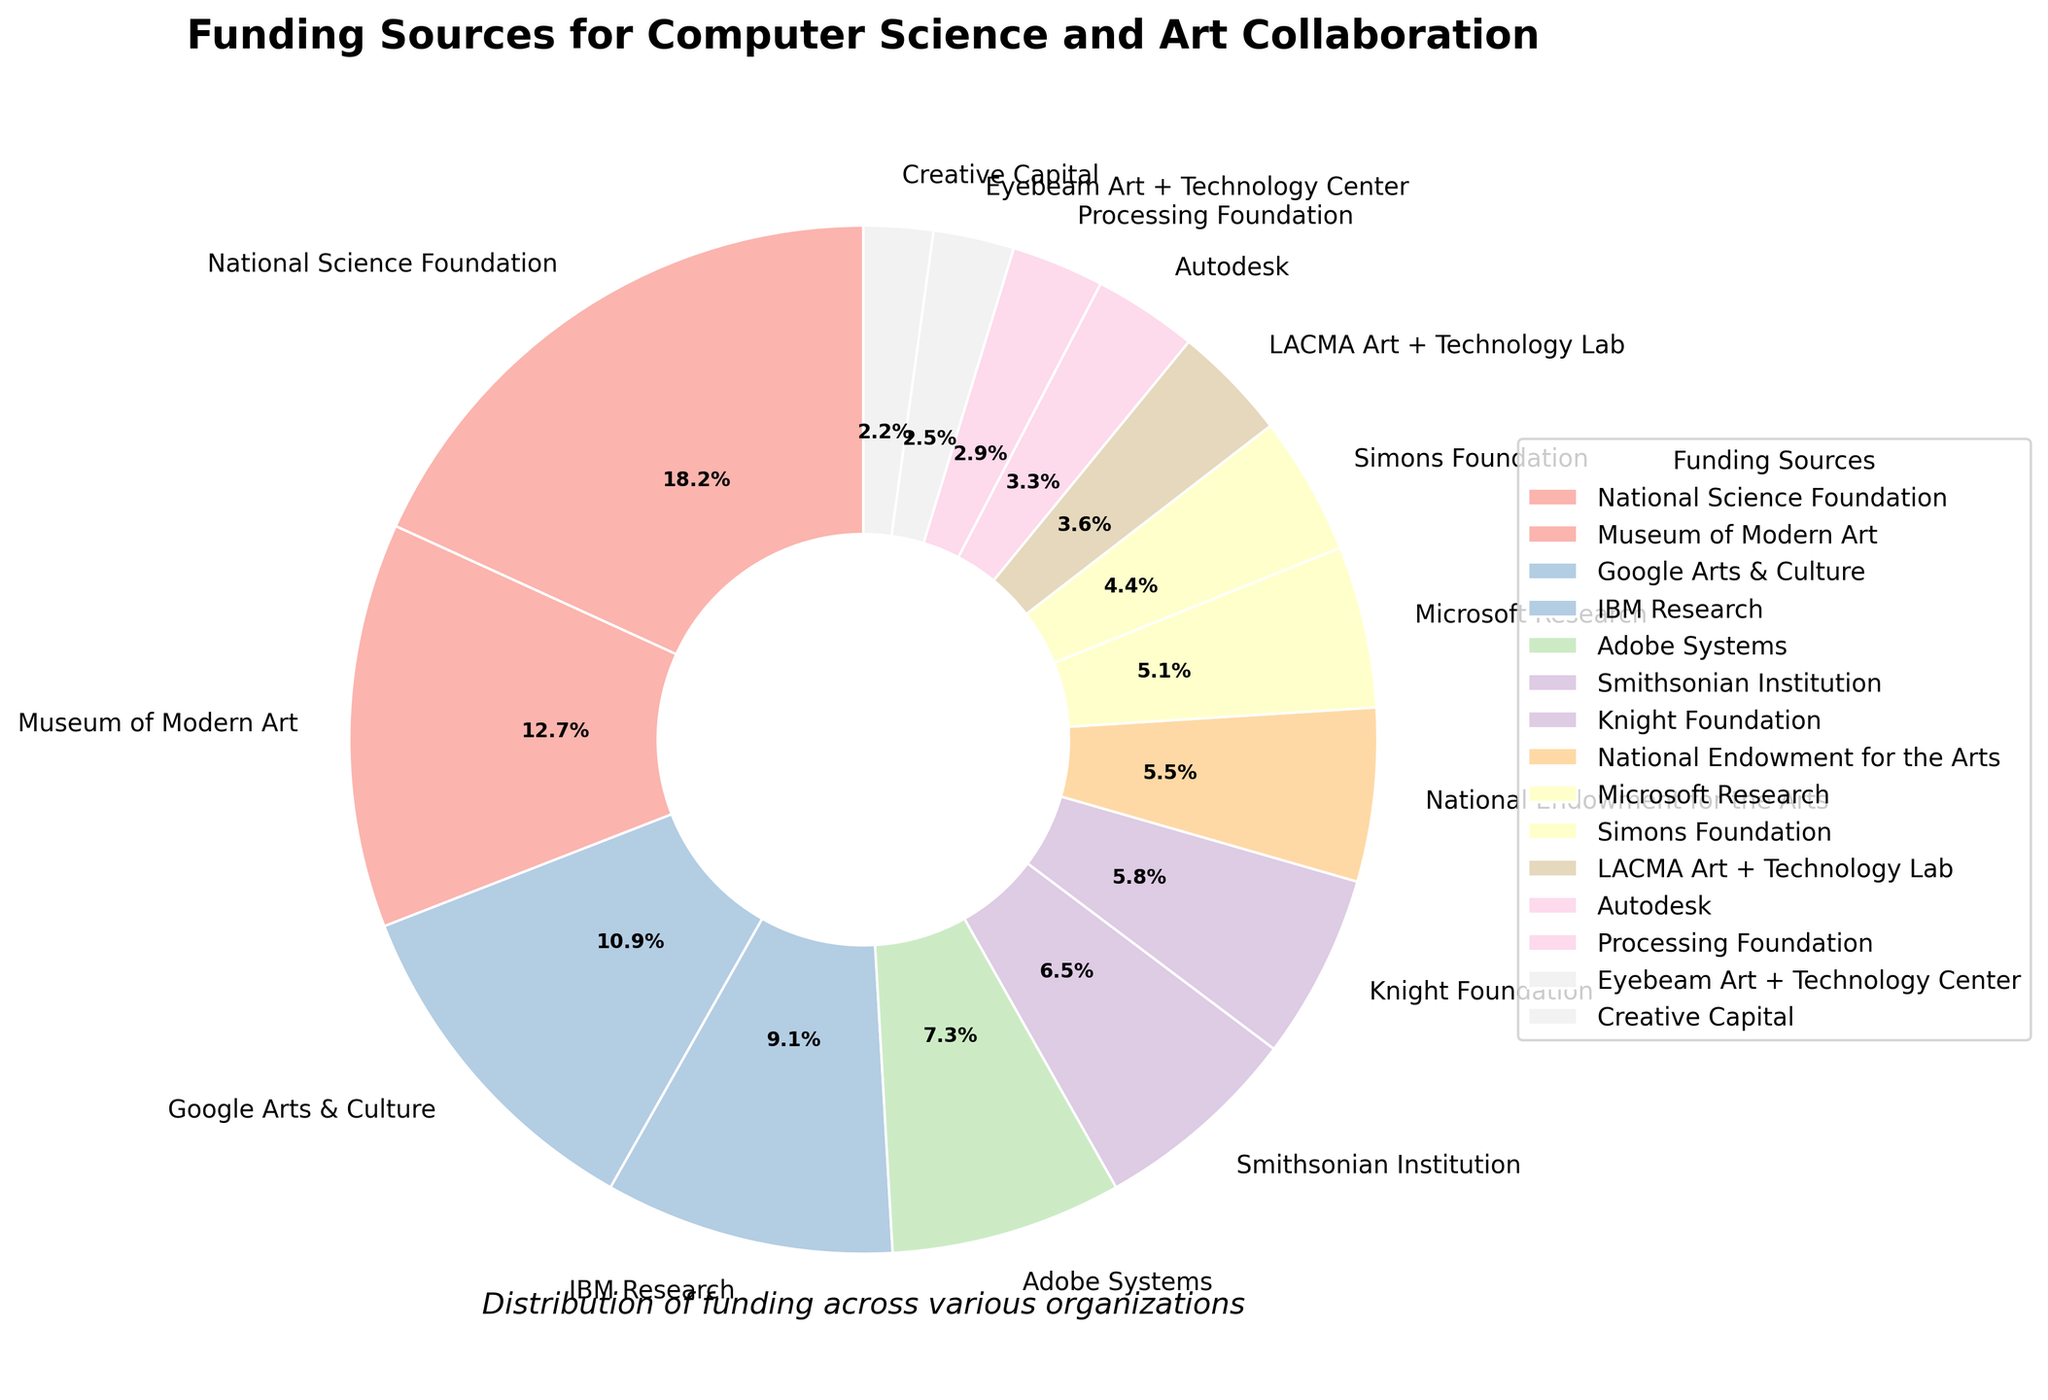Which funding source provided the largest contribution? The pie chart slices represent each funding source with percentages. The largest slice belongs to the National Science Foundation at 25.0%.
Answer: National Science Foundation What is the combined percentage of contributions from IBM Research and Google Arts & Culture? IBM Research contributes 12.5% and Google Arts & Culture contributes 15.0%. Adding these together, 12.5% + 15.0% = 27.5%.
Answer: 27.5% Which organization contributed more, Adobe Systems or Microsoft Research? Adobe Systems' slice is labeled at 10.0%, and Microsoft Research's slice is labeled at 7.0%. Since 10.0% is greater than 7.0%, Adobe Systems contributed more.
Answer: Adobe Systems How much of the total funding did the top three contributors provide? The top three contributors are National Science Foundation (25.0%), Museum of Modern Art (17.5%), and Google Arts & Culture (15.0%). Adding these together, 25.0% + 17.5% + 15.0% = 57.5%.
Answer: 57.5% Is the total amount provided by the Knight Foundation and the Smithsonian Institution higher than that provided by the Museum of Modern Art? Knight Foundation contributes 8.0% and Smithsonian Institution contributes 9.0%, so together they contribute 17.0%. The Museum of Modern Art provides 17.5%. Since 17.0% is less than 17.5%, the total from the Knight Foundation and Smithsonian Institution is not higher.
Answer: No Which has a larger contribution: Autodesk or Creative Capital? Autodesk's contribution slice is 4.5%, while Creative Capital's slice is 3.0%. Since 4.5% is greater than 3.0%, Autodesk has a larger contribution.
Answer: Autodesk How much more did Simons Foundation contribute compared to Processing Foundation? Simons Foundation contributes 6.0%, and Processing Foundation contributes 4.0%. The difference is 6.0% - 4.0% = 2.0%.
Answer: 2.0% What is the average contribution percentage for the top five funding sources? The top five contributors and their percentages are: National Science Foundation (25.0%), Museum of Modern Art (17.5%), Google Arts & Culture (15.0%), IBM Research (12.5%), and Adobe Systems (10.0%). Adding these, the sum is 25.0% + 17.5% + 15.0% + 12.5% + 10.0% = 80.0%. The average is 80.0% / 5 = 16.0%.
Answer: 16.0% How does Smithsonian Institution's contribution compare to LACMA Art + Technology Lab's? Smithsonian Institution contributes 9.0%, whereas LACMA Art + Technology Lab contributes 5.0%. Since 9.0% is greater than 5.0%, Smithsonian Institution's contribution is higher.
Answer: Higher 